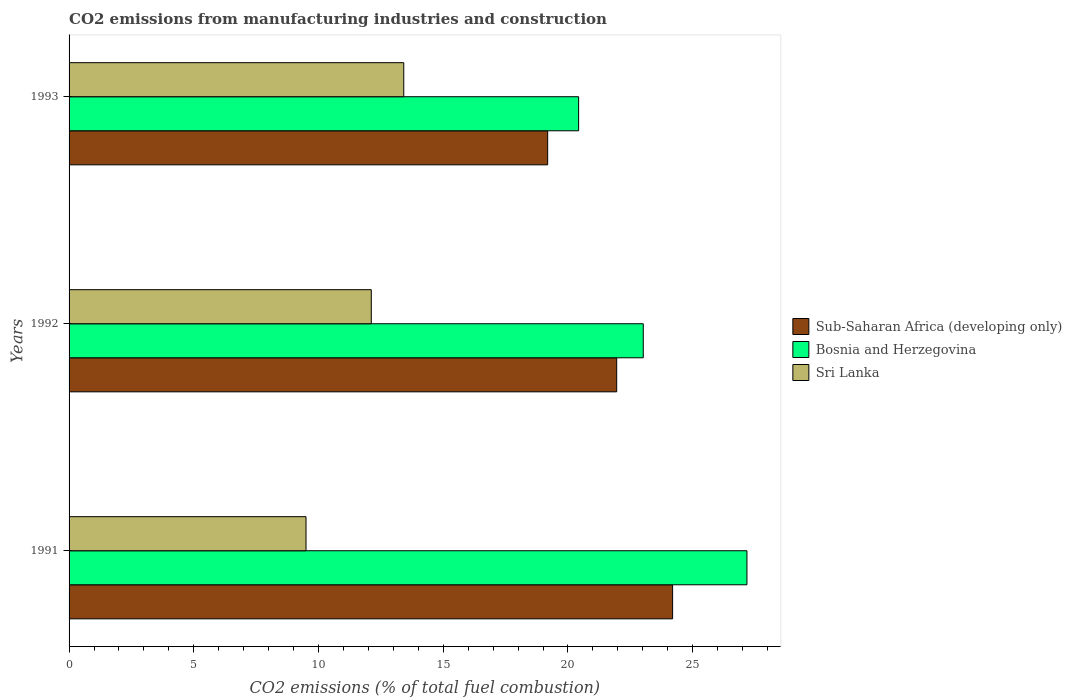How many different coloured bars are there?
Give a very brief answer. 3. Are the number of bars per tick equal to the number of legend labels?
Give a very brief answer. Yes. How many bars are there on the 2nd tick from the bottom?
Offer a terse response. 3. In how many cases, is the number of bars for a given year not equal to the number of legend labels?
Your answer should be very brief. 0. What is the amount of CO2 emitted in Bosnia and Herzegovina in 1992?
Ensure brevity in your answer.  23.02. Across all years, what is the maximum amount of CO2 emitted in Sri Lanka?
Your response must be concise. 13.42. Across all years, what is the minimum amount of CO2 emitted in Sub-Saharan Africa (developing only)?
Ensure brevity in your answer.  19.19. In which year was the amount of CO2 emitted in Sub-Saharan Africa (developing only) minimum?
Give a very brief answer. 1993. What is the total amount of CO2 emitted in Sri Lanka in the graph?
Offer a very short reply. 35.03. What is the difference between the amount of CO2 emitted in Sub-Saharan Africa (developing only) in 1992 and that in 1993?
Provide a succinct answer. 2.77. What is the difference between the amount of CO2 emitted in Bosnia and Herzegovina in 1992 and the amount of CO2 emitted in Sri Lanka in 1991?
Your answer should be compact. 13.52. What is the average amount of CO2 emitted in Bosnia and Herzegovina per year?
Ensure brevity in your answer.  23.54. In the year 1991, what is the difference between the amount of CO2 emitted in Sri Lanka and amount of CO2 emitted in Bosnia and Herzegovina?
Your answer should be very brief. -17.68. What is the ratio of the amount of CO2 emitted in Bosnia and Herzegovina in 1992 to that in 1993?
Provide a succinct answer. 1.13. Is the difference between the amount of CO2 emitted in Sri Lanka in 1991 and 1993 greater than the difference between the amount of CO2 emitted in Bosnia and Herzegovina in 1991 and 1993?
Offer a very short reply. No. What is the difference between the highest and the second highest amount of CO2 emitted in Bosnia and Herzegovina?
Offer a very short reply. 4.16. What is the difference between the highest and the lowest amount of CO2 emitted in Sub-Saharan Africa (developing only)?
Offer a very short reply. 5.01. In how many years, is the amount of CO2 emitted in Sri Lanka greater than the average amount of CO2 emitted in Sri Lanka taken over all years?
Keep it short and to the point. 2. What does the 2nd bar from the top in 1992 represents?
Your response must be concise. Bosnia and Herzegovina. What does the 2nd bar from the bottom in 1993 represents?
Your answer should be very brief. Bosnia and Herzegovina. Are all the bars in the graph horizontal?
Your answer should be compact. Yes. What is the difference between two consecutive major ticks on the X-axis?
Your answer should be very brief. 5. Are the values on the major ticks of X-axis written in scientific E-notation?
Offer a very short reply. No. Does the graph contain any zero values?
Provide a short and direct response. No. Does the graph contain grids?
Make the answer very short. No. Where does the legend appear in the graph?
Offer a very short reply. Center right. How many legend labels are there?
Give a very brief answer. 3. What is the title of the graph?
Ensure brevity in your answer.  CO2 emissions from manufacturing industries and construction. What is the label or title of the X-axis?
Your answer should be very brief. CO2 emissions (% of total fuel combustion). What is the label or title of the Y-axis?
Keep it short and to the point. Years. What is the CO2 emissions (% of total fuel combustion) in Sub-Saharan Africa (developing only) in 1991?
Provide a short and direct response. 24.19. What is the CO2 emissions (% of total fuel combustion) in Bosnia and Herzegovina in 1991?
Provide a succinct answer. 27.17. What is the CO2 emissions (% of total fuel combustion) of Sri Lanka in 1991?
Your answer should be compact. 9.5. What is the CO2 emissions (% of total fuel combustion) of Sub-Saharan Africa (developing only) in 1992?
Provide a short and direct response. 21.95. What is the CO2 emissions (% of total fuel combustion) in Bosnia and Herzegovina in 1992?
Your answer should be very brief. 23.02. What is the CO2 emissions (% of total fuel combustion) in Sri Lanka in 1992?
Keep it short and to the point. 12.11. What is the CO2 emissions (% of total fuel combustion) in Sub-Saharan Africa (developing only) in 1993?
Make the answer very short. 19.19. What is the CO2 emissions (% of total fuel combustion) of Bosnia and Herzegovina in 1993?
Provide a short and direct response. 20.43. What is the CO2 emissions (% of total fuel combustion) of Sri Lanka in 1993?
Offer a very short reply. 13.42. Across all years, what is the maximum CO2 emissions (% of total fuel combustion) in Sub-Saharan Africa (developing only)?
Give a very brief answer. 24.19. Across all years, what is the maximum CO2 emissions (% of total fuel combustion) of Bosnia and Herzegovina?
Provide a short and direct response. 27.17. Across all years, what is the maximum CO2 emissions (% of total fuel combustion) in Sri Lanka?
Offer a terse response. 13.42. Across all years, what is the minimum CO2 emissions (% of total fuel combustion) in Sub-Saharan Africa (developing only)?
Your answer should be compact. 19.19. Across all years, what is the minimum CO2 emissions (% of total fuel combustion) in Bosnia and Herzegovina?
Provide a succinct answer. 20.43. Across all years, what is the minimum CO2 emissions (% of total fuel combustion) in Sri Lanka?
Give a very brief answer. 9.5. What is the total CO2 emissions (% of total fuel combustion) in Sub-Saharan Africa (developing only) in the graph?
Offer a very short reply. 65.33. What is the total CO2 emissions (% of total fuel combustion) in Bosnia and Herzegovina in the graph?
Keep it short and to the point. 70.62. What is the total CO2 emissions (% of total fuel combustion) in Sri Lanka in the graph?
Your answer should be very brief. 35.03. What is the difference between the CO2 emissions (% of total fuel combustion) in Sub-Saharan Africa (developing only) in 1991 and that in 1992?
Offer a very short reply. 2.24. What is the difference between the CO2 emissions (% of total fuel combustion) in Bosnia and Herzegovina in 1991 and that in 1992?
Ensure brevity in your answer.  4.16. What is the difference between the CO2 emissions (% of total fuel combustion) in Sri Lanka in 1991 and that in 1992?
Make the answer very short. -2.62. What is the difference between the CO2 emissions (% of total fuel combustion) in Sub-Saharan Africa (developing only) in 1991 and that in 1993?
Offer a very short reply. 5.01. What is the difference between the CO2 emissions (% of total fuel combustion) of Bosnia and Herzegovina in 1991 and that in 1993?
Keep it short and to the point. 6.75. What is the difference between the CO2 emissions (% of total fuel combustion) of Sri Lanka in 1991 and that in 1993?
Keep it short and to the point. -3.92. What is the difference between the CO2 emissions (% of total fuel combustion) of Sub-Saharan Africa (developing only) in 1992 and that in 1993?
Make the answer very short. 2.77. What is the difference between the CO2 emissions (% of total fuel combustion) of Bosnia and Herzegovina in 1992 and that in 1993?
Provide a succinct answer. 2.59. What is the difference between the CO2 emissions (% of total fuel combustion) of Sri Lanka in 1992 and that in 1993?
Provide a succinct answer. -1.3. What is the difference between the CO2 emissions (% of total fuel combustion) of Sub-Saharan Africa (developing only) in 1991 and the CO2 emissions (% of total fuel combustion) of Bosnia and Herzegovina in 1992?
Provide a short and direct response. 1.18. What is the difference between the CO2 emissions (% of total fuel combustion) in Sub-Saharan Africa (developing only) in 1991 and the CO2 emissions (% of total fuel combustion) in Sri Lanka in 1992?
Your response must be concise. 12.08. What is the difference between the CO2 emissions (% of total fuel combustion) of Bosnia and Herzegovina in 1991 and the CO2 emissions (% of total fuel combustion) of Sri Lanka in 1992?
Your response must be concise. 15.06. What is the difference between the CO2 emissions (% of total fuel combustion) of Sub-Saharan Africa (developing only) in 1991 and the CO2 emissions (% of total fuel combustion) of Bosnia and Herzegovina in 1993?
Keep it short and to the point. 3.77. What is the difference between the CO2 emissions (% of total fuel combustion) in Sub-Saharan Africa (developing only) in 1991 and the CO2 emissions (% of total fuel combustion) in Sri Lanka in 1993?
Offer a terse response. 10.78. What is the difference between the CO2 emissions (% of total fuel combustion) of Bosnia and Herzegovina in 1991 and the CO2 emissions (% of total fuel combustion) of Sri Lanka in 1993?
Your response must be concise. 13.76. What is the difference between the CO2 emissions (% of total fuel combustion) in Sub-Saharan Africa (developing only) in 1992 and the CO2 emissions (% of total fuel combustion) in Bosnia and Herzegovina in 1993?
Provide a short and direct response. 1.53. What is the difference between the CO2 emissions (% of total fuel combustion) of Sub-Saharan Africa (developing only) in 1992 and the CO2 emissions (% of total fuel combustion) of Sri Lanka in 1993?
Provide a succinct answer. 8.54. What is the difference between the CO2 emissions (% of total fuel combustion) in Bosnia and Herzegovina in 1992 and the CO2 emissions (% of total fuel combustion) in Sri Lanka in 1993?
Keep it short and to the point. 9.6. What is the average CO2 emissions (% of total fuel combustion) of Sub-Saharan Africa (developing only) per year?
Give a very brief answer. 21.78. What is the average CO2 emissions (% of total fuel combustion) of Bosnia and Herzegovina per year?
Give a very brief answer. 23.54. What is the average CO2 emissions (% of total fuel combustion) in Sri Lanka per year?
Give a very brief answer. 11.68. In the year 1991, what is the difference between the CO2 emissions (% of total fuel combustion) in Sub-Saharan Africa (developing only) and CO2 emissions (% of total fuel combustion) in Bosnia and Herzegovina?
Offer a terse response. -2.98. In the year 1991, what is the difference between the CO2 emissions (% of total fuel combustion) of Sub-Saharan Africa (developing only) and CO2 emissions (% of total fuel combustion) of Sri Lanka?
Your response must be concise. 14.7. In the year 1991, what is the difference between the CO2 emissions (% of total fuel combustion) in Bosnia and Herzegovina and CO2 emissions (% of total fuel combustion) in Sri Lanka?
Make the answer very short. 17.68. In the year 1992, what is the difference between the CO2 emissions (% of total fuel combustion) of Sub-Saharan Africa (developing only) and CO2 emissions (% of total fuel combustion) of Bosnia and Herzegovina?
Offer a terse response. -1.07. In the year 1992, what is the difference between the CO2 emissions (% of total fuel combustion) in Sub-Saharan Africa (developing only) and CO2 emissions (% of total fuel combustion) in Sri Lanka?
Keep it short and to the point. 9.84. In the year 1992, what is the difference between the CO2 emissions (% of total fuel combustion) in Bosnia and Herzegovina and CO2 emissions (% of total fuel combustion) in Sri Lanka?
Ensure brevity in your answer.  10.9. In the year 1993, what is the difference between the CO2 emissions (% of total fuel combustion) in Sub-Saharan Africa (developing only) and CO2 emissions (% of total fuel combustion) in Bosnia and Herzegovina?
Your answer should be compact. -1.24. In the year 1993, what is the difference between the CO2 emissions (% of total fuel combustion) in Sub-Saharan Africa (developing only) and CO2 emissions (% of total fuel combustion) in Sri Lanka?
Your answer should be very brief. 5.77. In the year 1993, what is the difference between the CO2 emissions (% of total fuel combustion) of Bosnia and Herzegovina and CO2 emissions (% of total fuel combustion) of Sri Lanka?
Make the answer very short. 7.01. What is the ratio of the CO2 emissions (% of total fuel combustion) of Sub-Saharan Africa (developing only) in 1991 to that in 1992?
Provide a short and direct response. 1.1. What is the ratio of the CO2 emissions (% of total fuel combustion) of Bosnia and Herzegovina in 1991 to that in 1992?
Make the answer very short. 1.18. What is the ratio of the CO2 emissions (% of total fuel combustion) of Sri Lanka in 1991 to that in 1992?
Offer a terse response. 0.78. What is the ratio of the CO2 emissions (% of total fuel combustion) in Sub-Saharan Africa (developing only) in 1991 to that in 1993?
Give a very brief answer. 1.26. What is the ratio of the CO2 emissions (% of total fuel combustion) in Bosnia and Herzegovina in 1991 to that in 1993?
Offer a terse response. 1.33. What is the ratio of the CO2 emissions (% of total fuel combustion) in Sri Lanka in 1991 to that in 1993?
Give a very brief answer. 0.71. What is the ratio of the CO2 emissions (% of total fuel combustion) in Sub-Saharan Africa (developing only) in 1992 to that in 1993?
Offer a very short reply. 1.14. What is the ratio of the CO2 emissions (% of total fuel combustion) of Bosnia and Herzegovina in 1992 to that in 1993?
Offer a terse response. 1.13. What is the ratio of the CO2 emissions (% of total fuel combustion) in Sri Lanka in 1992 to that in 1993?
Your answer should be compact. 0.9. What is the difference between the highest and the second highest CO2 emissions (% of total fuel combustion) of Sub-Saharan Africa (developing only)?
Keep it short and to the point. 2.24. What is the difference between the highest and the second highest CO2 emissions (% of total fuel combustion) in Bosnia and Herzegovina?
Offer a terse response. 4.16. What is the difference between the highest and the second highest CO2 emissions (% of total fuel combustion) of Sri Lanka?
Your answer should be very brief. 1.3. What is the difference between the highest and the lowest CO2 emissions (% of total fuel combustion) of Sub-Saharan Africa (developing only)?
Offer a very short reply. 5.01. What is the difference between the highest and the lowest CO2 emissions (% of total fuel combustion) in Bosnia and Herzegovina?
Your response must be concise. 6.75. What is the difference between the highest and the lowest CO2 emissions (% of total fuel combustion) of Sri Lanka?
Give a very brief answer. 3.92. 